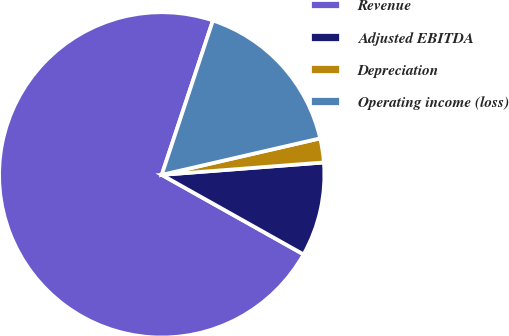Convert chart to OTSL. <chart><loc_0><loc_0><loc_500><loc_500><pie_chart><fcel>Revenue<fcel>Adjusted EBITDA<fcel>Depreciation<fcel>Operating income (loss)<nl><fcel>71.96%<fcel>9.35%<fcel>2.39%<fcel>16.3%<nl></chart> 